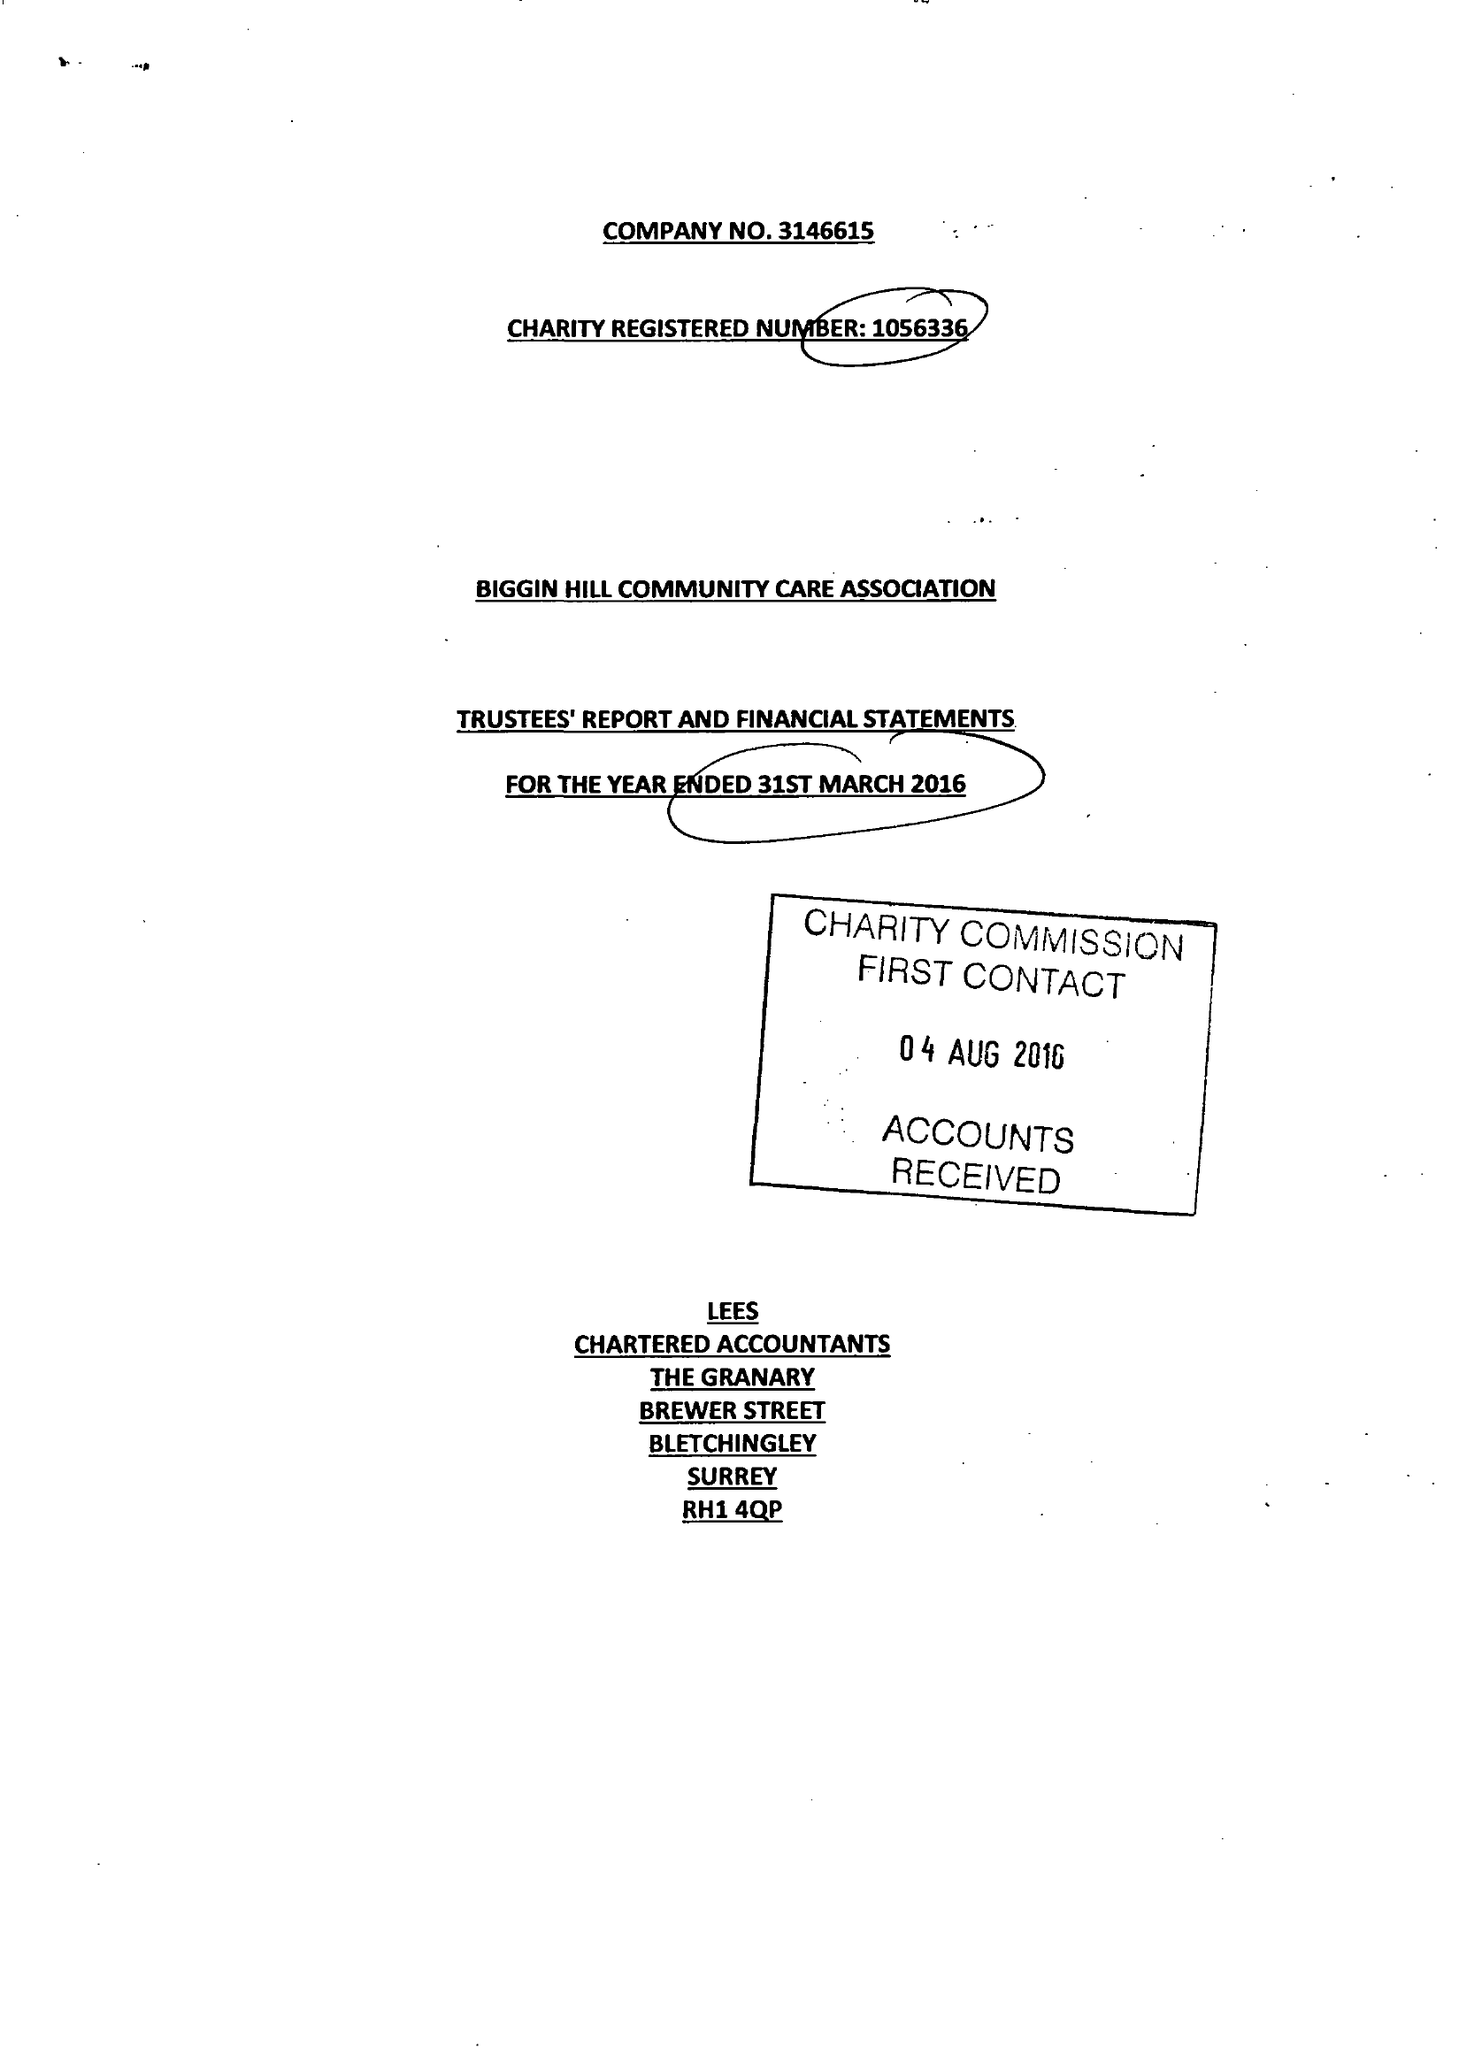What is the value for the address__post_town?
Answer the question using a single word or phrase. WESTERHAM 